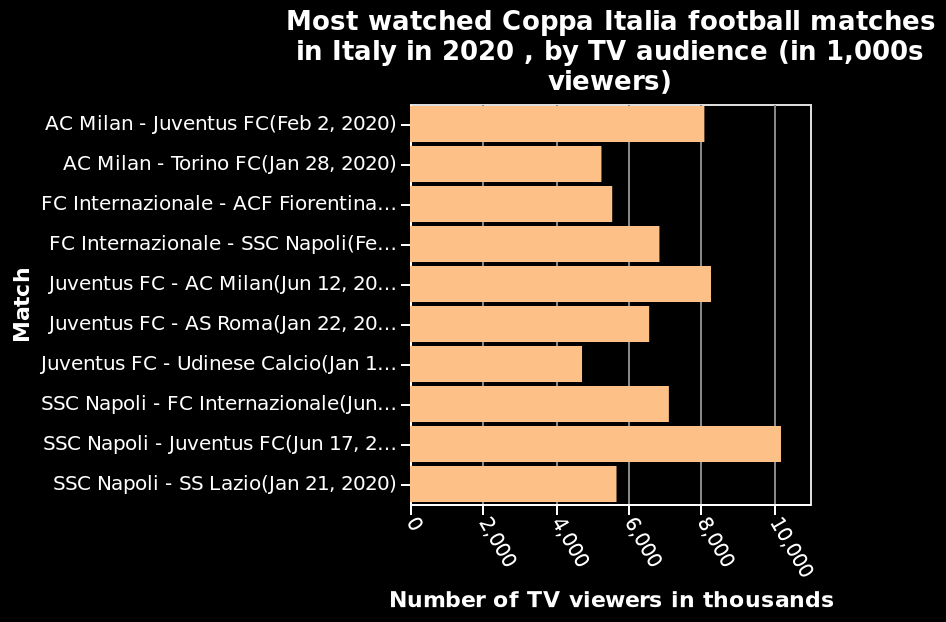<image>
Offer a thorough analysis of the image. The highest audience numbers was for the SSC Napoli-Juventus gameThe lowest audience members was for the Juventus - Udinese Calcio. Which match had the highest TV viewership in the Coppa Italia in Italy in 2020?  The match with the highest TV viewership in the Coppa Italia in Italy in 2020 is AC Milan - Juventus FC (Feb 2, 2020). What was the TV viewership for the AC Milan - Juventus FC match in the Coppa Italia in Italy in 2020?  The TV viewership for the AC Milan - Juventus FC match in the Coppa Italia in Italy in 2020 was in the range of 0 to 10,000 viewers. 